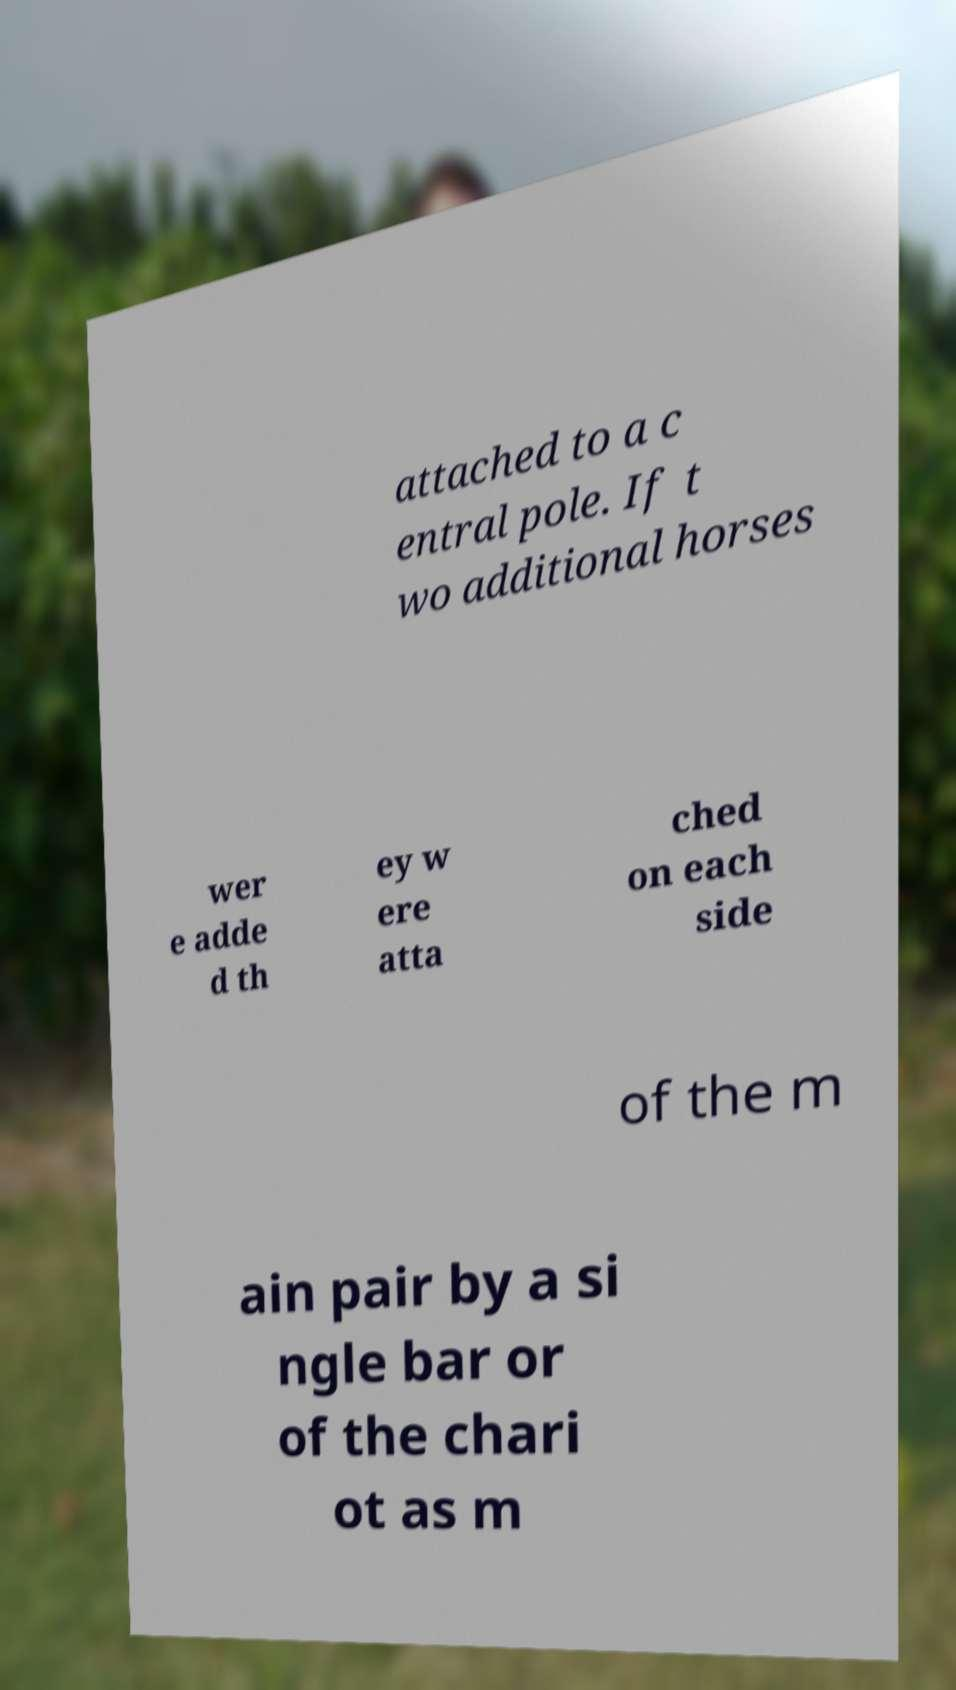There's text embedded in this image that I need extracted. Can you transcribe it verbatim? attached to a c entral pole. If t wo additional horses wer e adde d th ey w ere atta ched on each side of the m ain pair by a si ngle bar or of the chari ot as m 